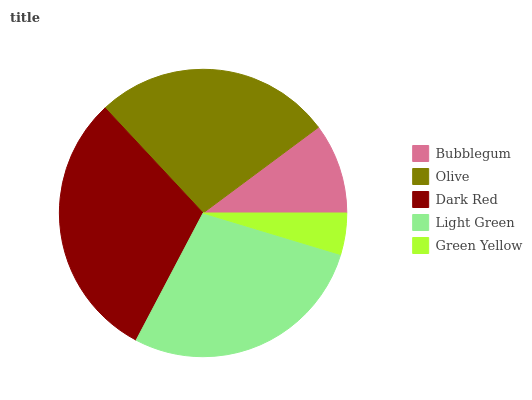Is Green Yellow the minimum?
Answer yes or no. Yes. Is Dark Red the maximum?
Answer yes or no. Yes. Is Olive the minimum?
Answer yes or no. No. Is Olive the maximum?
Answer yes or no. No. Is Olive greater than Bubblegum?
Answer yes or no. Yes. Is Bubblegum less than Olive?
Answer yes or no. Yes. Is Bubblegum greater than Olive?
Answer yes or no. No. Is Olive less than Bubblegum?
Answer yes or no. No. Is Olive the high median?
Answer yes or no. Yes. Is Olive the low median?
Answer yes or no. Yes. Is Bubblegum the high median?
Answer yes or no. No. Is Green Yellow the low median?
Answer yes or no. No. 